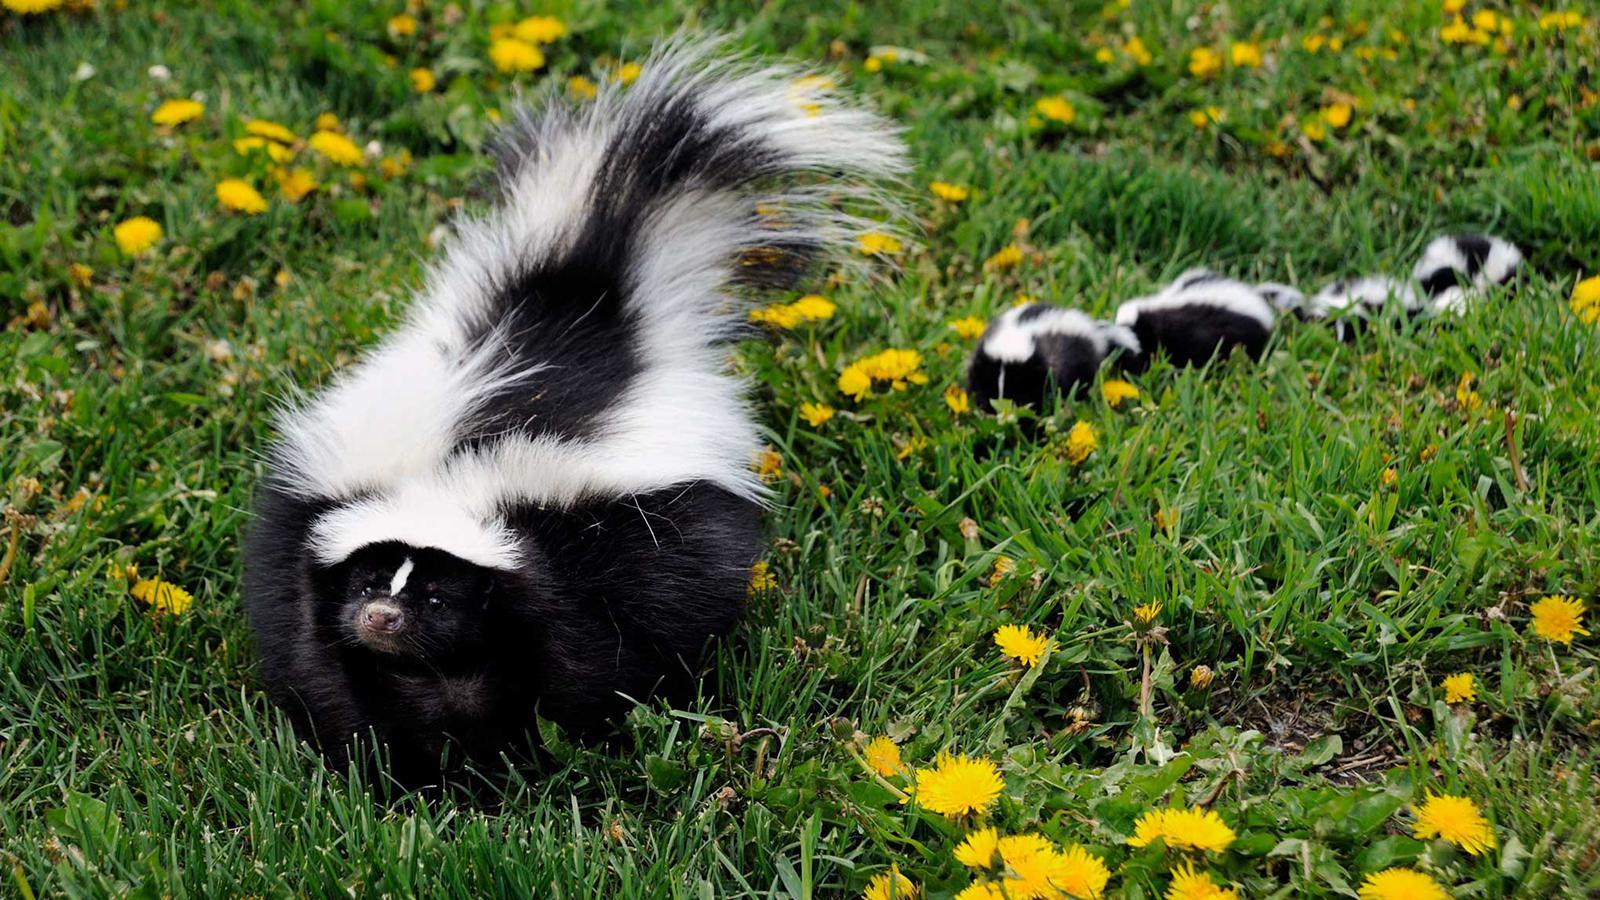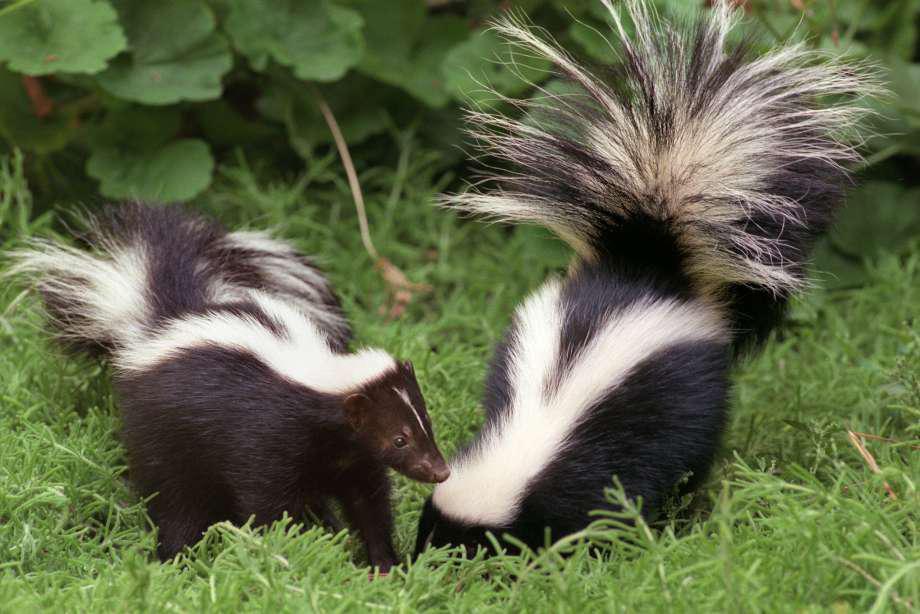The first image is the image on the left, the second image is the image on the right. Considering the images on both sides, is "The combined images contain at least four skunks, including two side-by side with their faces pointing toward each other." valid? Answer yes or no. Yes. The first image is the image on the left, the second image is the image on the right. Examine the images to the left and right. Is the description "Three or fewer mammals are visible." accurate? Answer yes or no. No. 